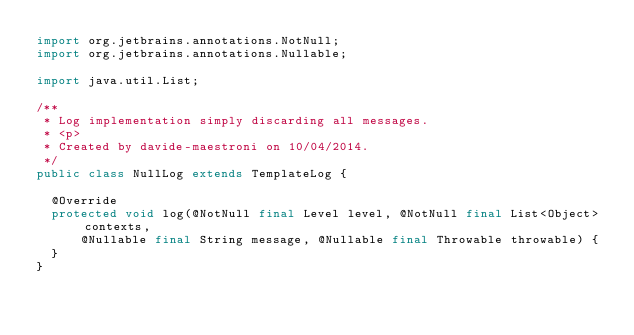Convert code to text. <code><loc_0><loc_0><loc_500><loc_500><_Java_>import org.jetbrains.annotations.NotNull;
import org.jetbrains.annotations.Nullable;

import java.util.List;

/**
 * Log implementation simply discarding all messages.
 * <p>
 * Created by davide-maestroni on 10/04/2014.
 */
public class NullLog extends TemplateLog {

  @Override
  protected void log(@NotNull final Level level, @NotNull final List<Object> contexts,
      @Nullable final String message, @Nullable final Throwable throwable) {
  }
}
</code> 